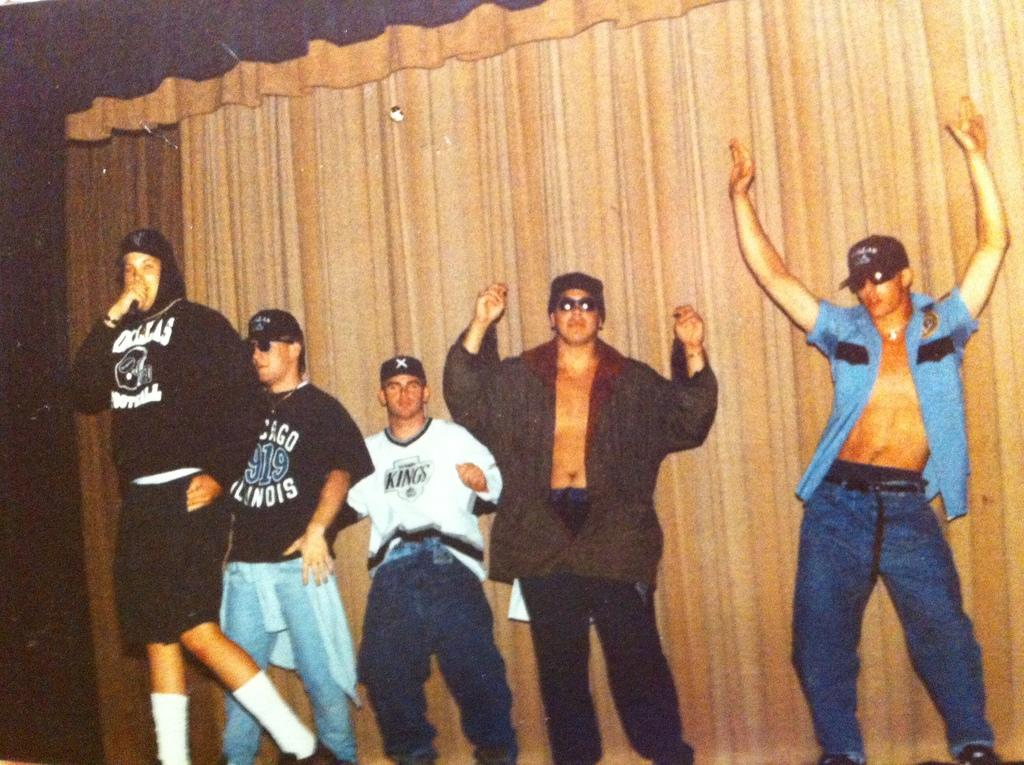<image>
Summarize the visual content of the image. The man in the white shirt is representing the Kings 